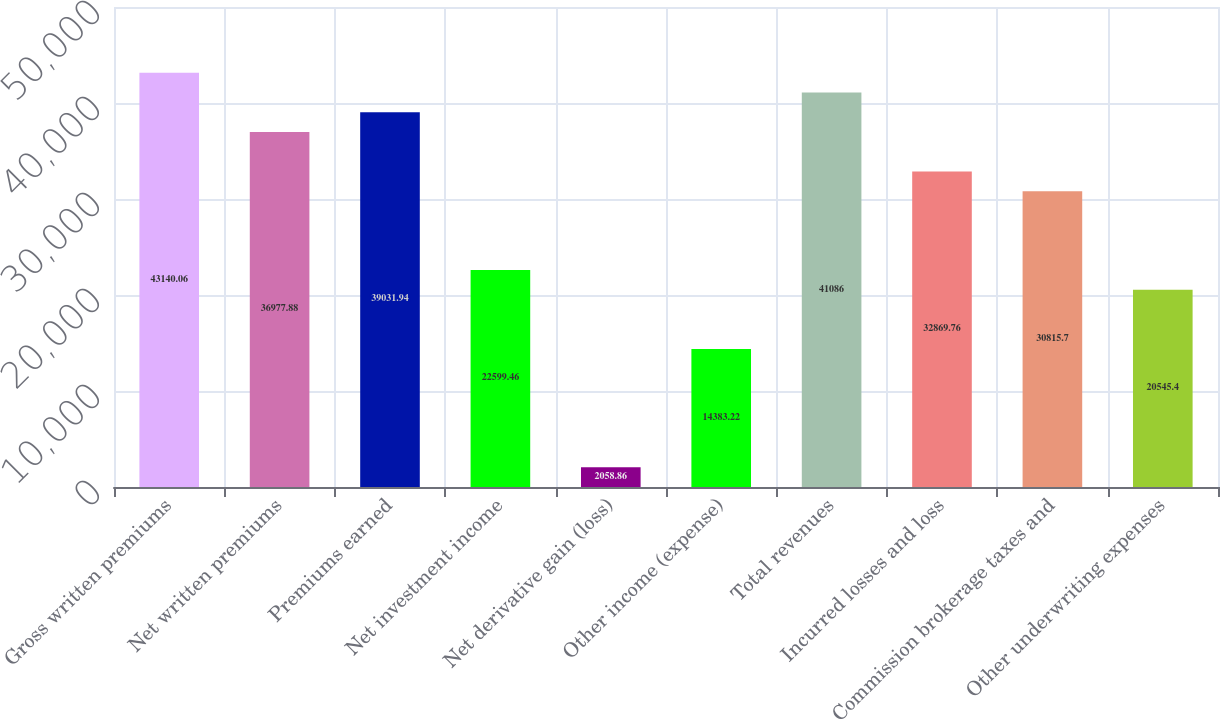Convert chart. <chart><loc_0><loc_0><loc_500><loc_500><bar_chart><fcel>Gross written premiums<fcel>Net written premiums<fcel>Premiums earned<fcel>Net investment income<fcel>Net derivative gain (loss)<fcel>Other income (expense)<fcel>Total revenues<fcel>Incurred losses and loss<fcel>Commission brokerage taxes and<fcel>Other underwriting expenses<nl><fcel>43140.1<fcel>36977.9<fcel>39031.9<fcel>22599.5<fcel>2058.86<fcel>14383.2<fcel>41086<fcel>32869.8<fcel>30815.7<fcel>20545.4<nl></chart> 